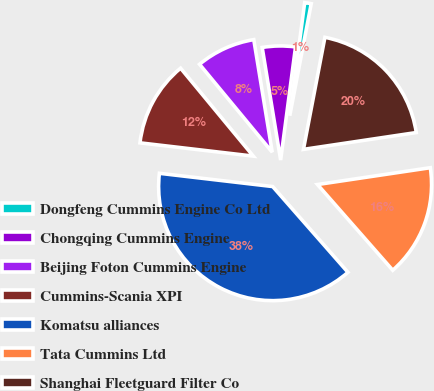Convert chart. <chart><loc_0><loc_0><loc_500><loc_500><pie_chart><fcel>Dongfeng Cummins Engine Co Ltd<fcel>Chongqing Cummins Engine<fcel>Beijing Foton Cummins Engine<fcel>Cummins-Scania XPI<fcel>Komatsu alliances<fcel>Tata Cummins Ltd<fcel>Shanghai Fleetguard Filter Co<nl><fcel>0.93%<fcel>4.67%<fcel>8.41%<fcel>12.15%<fcel>38.32%<fcel>15.89%<fcel>19.63%<nl></chart> 